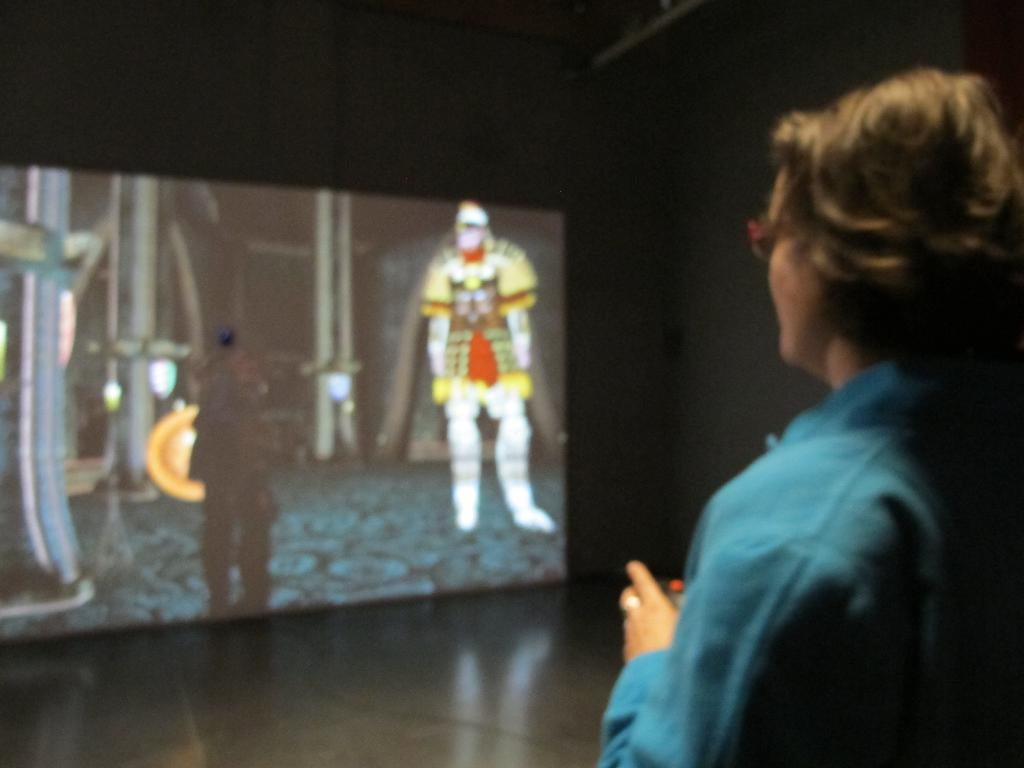What is the position of the woman in the image? The woman is standing on the right side of the image. What surface is the woman standing on? The woman is standing on the floor. What electronic device is present in the image? There is a digital screen present in the image. What type of content is displayed on the screen? Something cartoon is running on the screen. What type of powder is being used by the woman in the image? There is no powder visible or mentioned in the image. 